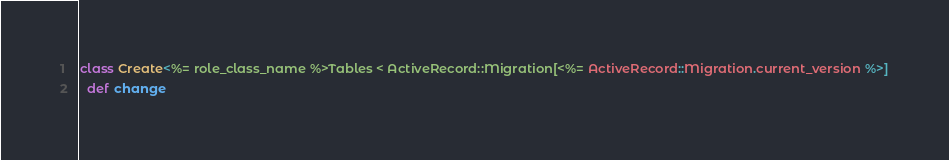<code> <loc_0><loc_0><loc_500><loc_500><_Ruby_>class Create<%= role_class_name %>Tables < ActiveRecord::Migration[<%= ActiveRecord::Migration.current_version %>]
  def change</code> 